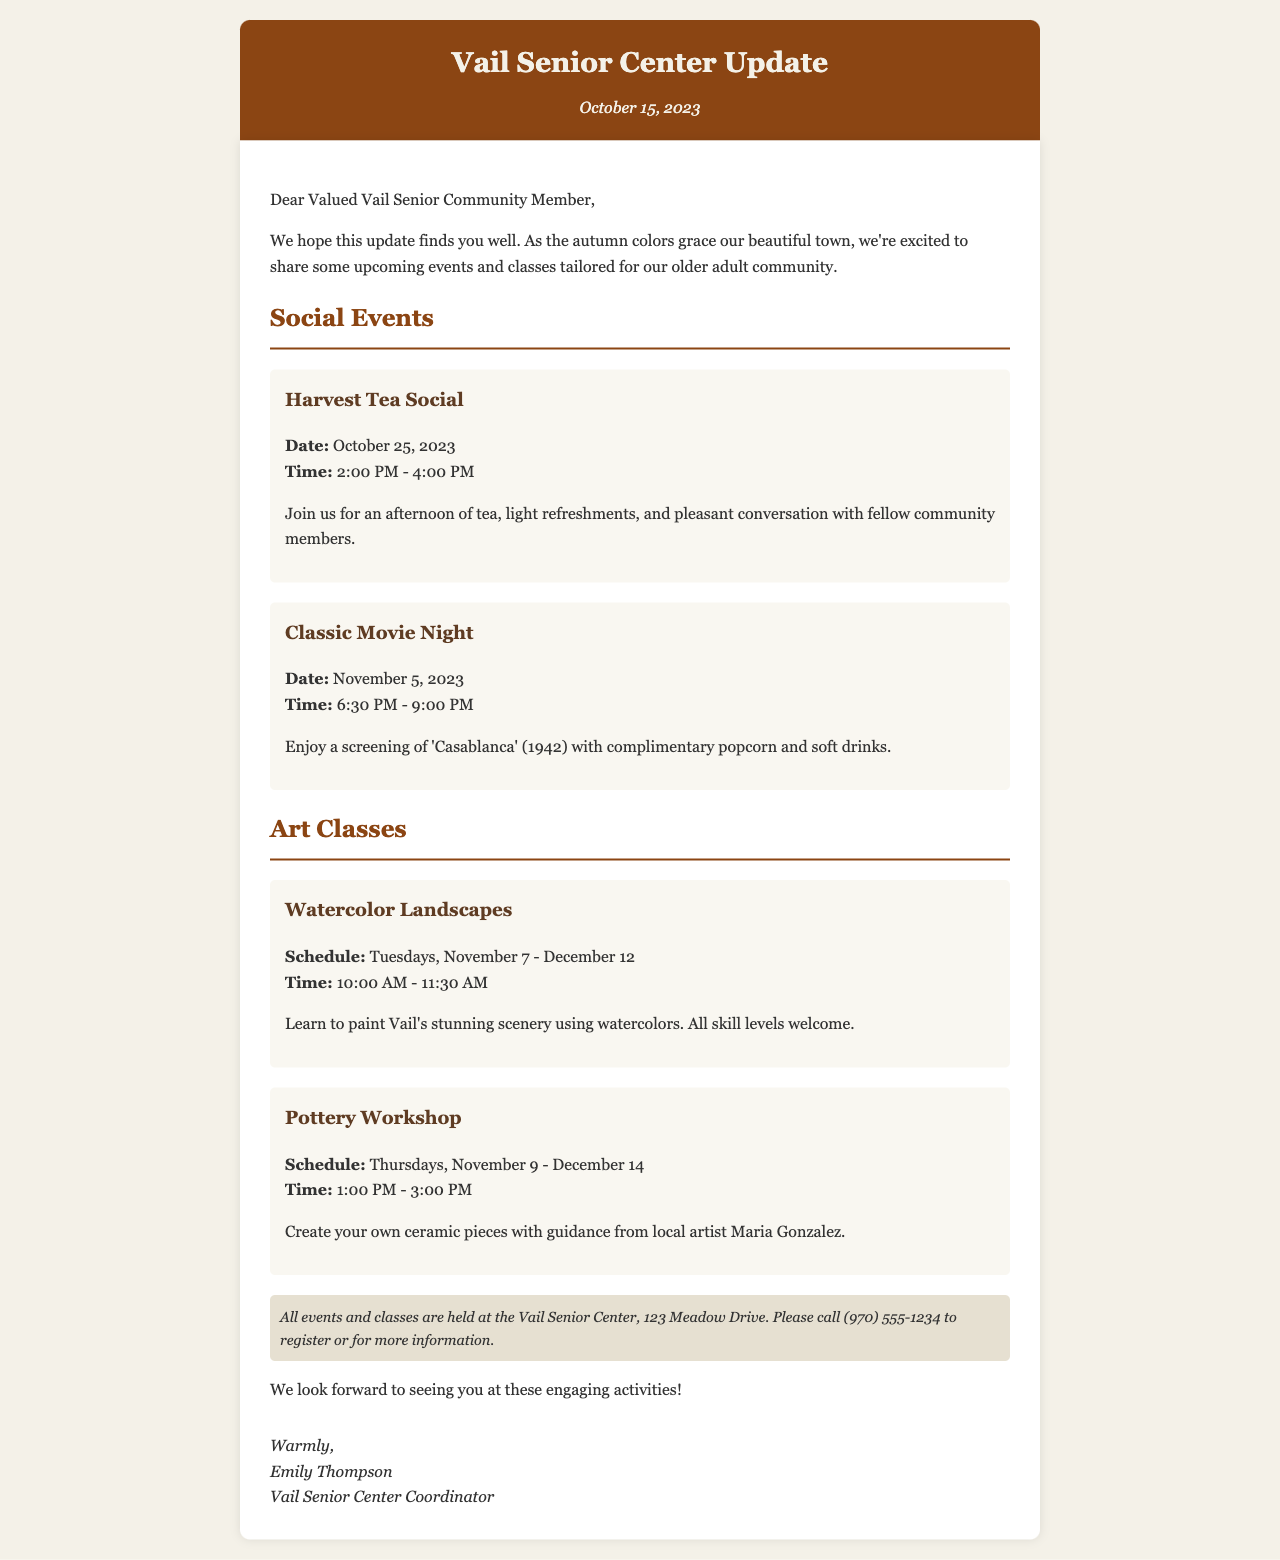what is the date of the Harvest Tea Social? The date for the Harvest Tea Social is explicitly mentioned in the document as October 25, 2023.
Answer: October 25, 2023 what time does the Classic Movie Night start? The starting time for the Classic Movie Night is specified in the document as 6:30 PM.
Answer: 6:30 PM who is the instructor for the Pottery Workshop? The document identifies local artist Maria Gonzalez as the instructor for the Pottery Workshop.
Answer: Maria Gonzalez how long does the Watercolor Landscapes class run? The schedule for the Watercolor Landscapes class indicates it runs from November 7 to December 12, which is a duration of six weeks.
Answer: six weeks what is the address of the Vail Senior Center? The document provides the address of the Vail Senior Center as 123 Meadow Drive.
Answer: 123 Meadow Drive what type of movie will be screened during the Classic Movie Night? The film being screened is 'Casablanca,' which is noted in the information about the Classic Movie Night.
Answer: 'Casablanca' how many classes are mentioned in the document? The document lists two art classes: Watercolor Landscapes and Pottery Workshop, which sums up to two.
Answer: two what additional service is mentioned for the events and classes? The document notes that attendees can call (970) 555-1234 for registration or more information regarding the events and classes.
Answer: call (970) 555-1234 